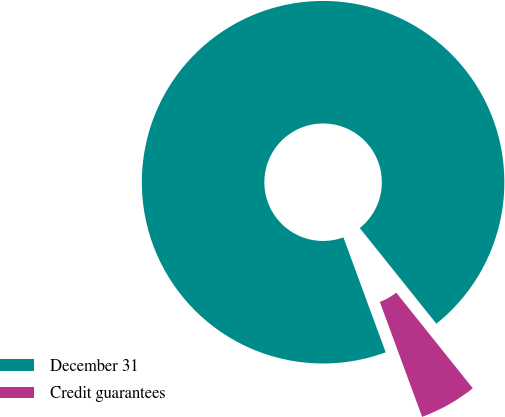<chart> <loc_0><loc_0><loc_500><loc_500><pie_chart><fcel>December 31<fcel>Credit guarantees<nl><fcel>94.87%<fcel>5.13%<nl></chart> 